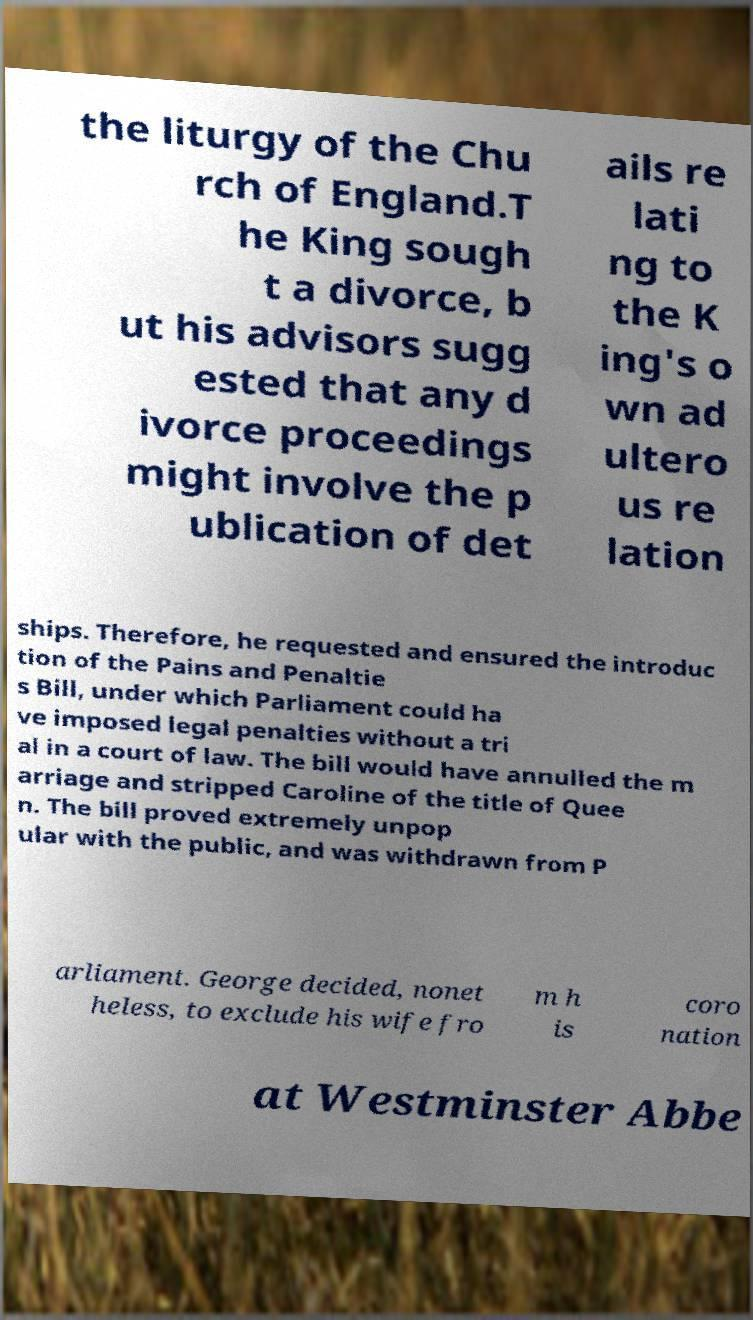Please identify and transcribe the text found in this image. the liturgy of the Chu rch of England.T he King sough t a divorce, b ut his advisors sugg ested that any d ivorce proceedings might involve the p ublication of det ails re lati ng to the K ing's o wn ad ultero us re lation ships. Therefore, he requested and ensured the introduc tion of the Pains and Penaltie s Bill, under which Parliament could ha ve imposed legal penalties without a tri al in a court of law. The bill would have annulled the m arriage and stripped Caroline of the title of Quee n. The bill proved extremely unpop ular with the public, and was withdrawn from P arliament. George decided, nonet heless, to exclude his wife fro m h is coro nation at Westminster Abbe 